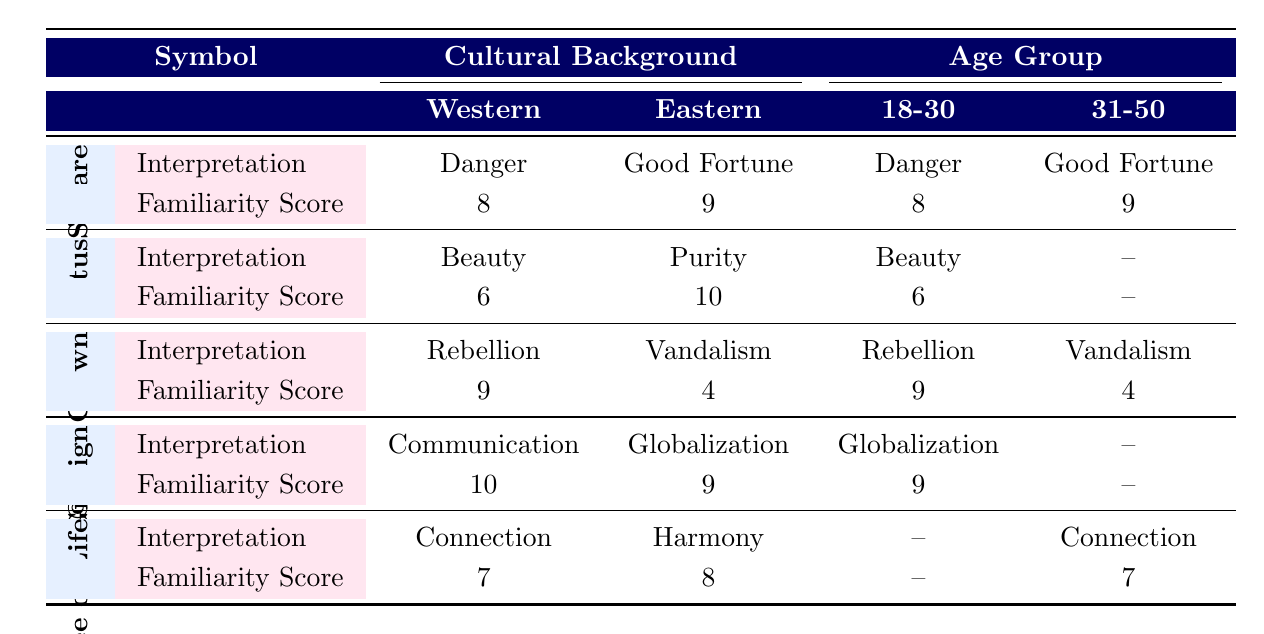What is the interpretation of the "Red Square" symbol by attendees from the Western cultural background? The table lists the symbol "Red Square" under the Western cultural background, showing its interpretation as "Danger."
Answer: Danger How many symbols have an interpretation of "Purity"? The "Lotus" symbol under the Eastern cultural background has an interpretation of "Purity." Therefore, only one symbol has that interpretation.
Answer: 1 What is the familiarity score for the "Graffiti Crown" symbol interpreted as "Rebellion" by attendees aged 18-30? Looking at the "Graffiti Crown" symbol row in the table, the familiarity score for the Western cultural background aged 18-30 is 9.
Answer: 9 Is the emotional response to the "Tree of Life" symbol consistent across all age groups? The "Tree of Life" symbol does not have an emotional response listed for the 18-30 age group, so it cannot be considered consistent.
Answer: No What is the average familiarity score for symbols interpreted as "Connection" across different cultural backgrounds? The only symbol interpreted as "Connection" is the "Tree of Life" with a familiarity score of 7 for the Western background and 8 for the Eastern background, leading to an average calculation: (7 + 8) / 2 = 7.5.
Answer: 7.5 Which cultural background regards the "Lotus" symbol as "Beauty"? The table indicates that the "Lotus" symbol is interpreted as "Beauty" by attendees from the Western cultural background.
Answer: Western What is the difference in familiarity scores between the "Red Square" and "Tree of Life" symbols for attendees in the 31-50 age group from the Western cultural background? For the "Red Square," the familiarity score is 8, and for the "Tree of Life," it is 7. The difference is: 8 - 7 = 1.
Answer: 1 How many symbols have a higher emotional response than "Caution" from attendees interpreting "Red Square"? The only symbol with a higher emotional response (which is classified as "Joy" for "Good Fortune") is "Red Square" interpreted by Eastern attendees. Therefore, only one symbol meets this criterion.
Answer: 1 Based on familiarity scores, which cultural group has the overall highest score? The Eastern cultural background has the highest familiarity score for the "Lotus" symbol at 10, while the highest for the Western is 10 for the "@ Sign." Therefore, there is no single group with the highest score collectively.
Answer: Eastern and Western (tie at 10) 